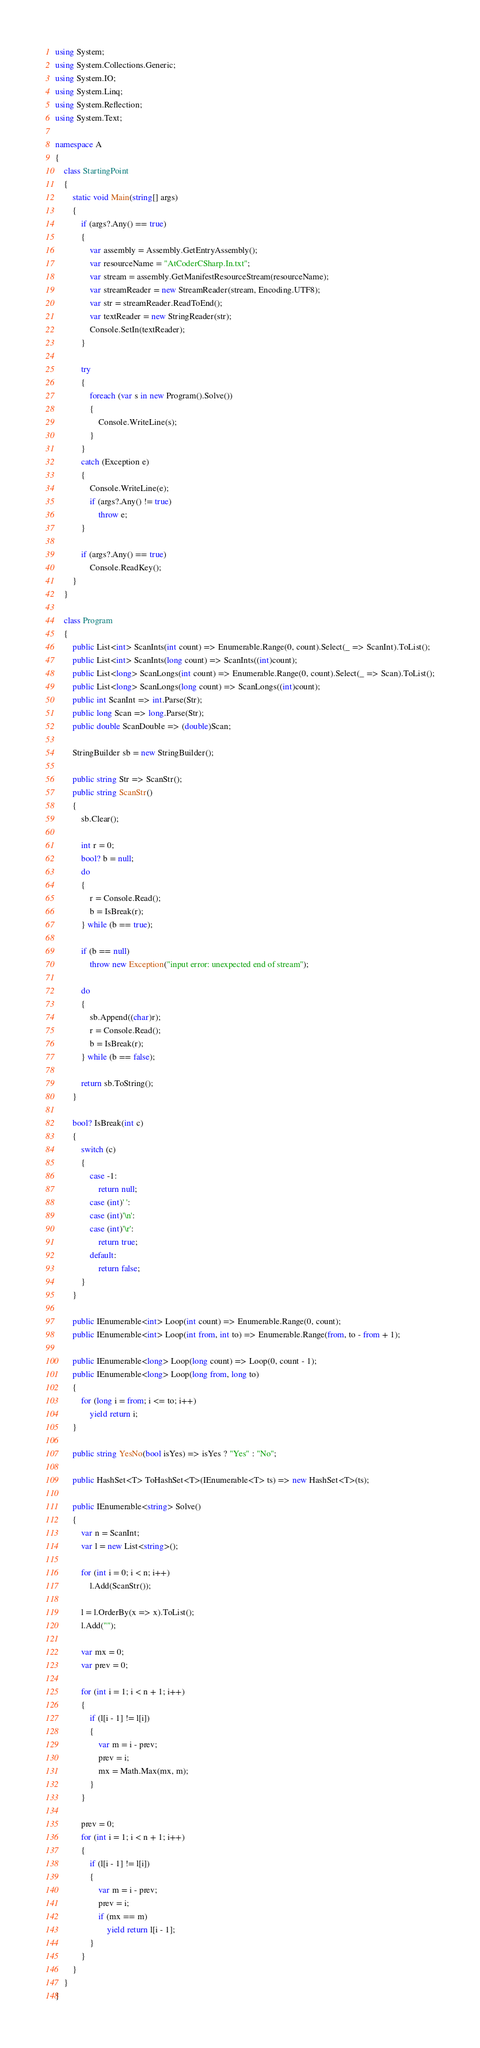Convert code to text. <code><loc_0><loc_0><loc_500><loc_500><_C#_>using System;
using System.Collections.Generic;
using System.IO;
using System.Linq;
using System.Reflection;
using System.Text;

namespace A
{
    class StartingPoint
    {
        static void Main(string[] args)
        {
            if (args?.Any() == true)
            {
                var assembly = Assembly.GetEntryAssembly();
                var resourceName = "AtCoderCSharp.In.txt";
                var stream = assembly.GetManifestResourceStream(resourceName);
                var streamReader = new StreamReader(stream, Encoding.UTF8);
                var str = streamReader.ReadToEnd();
                var textReader = new StringReader(str);
                Console.SetIn(textReader);
            }

            try
            {
                foreach (var s in new Program().Solve())
                {
                    Console.WriteLine(s);
                }
            }
            catch (Exception e)
            {
                Console.WriteLine(e);
                if (args?.Any() != true)
                    throw e;
            }

            if (args?.Any() == true)
                Console.ReadKey();
        }
    }

    class Program
    {
        public List<int> ScanInts(int count) => Enumerable.Range(0, count).Select(_ => ScanInt).ToList();
        public List<int> ScanInts(long count) => ScanInts((int)count);
        public List<long> ScanLongs(int count) => Enumerable.Range(0, count).Select(_ => Scan).ToList();
        public List<long> ScanLongs(long count) => ScanLongs((int)count);
        public int ScanInt => int.Parse(Str);
        public long Scan => long.Parse(Str);
        public double ScanDouble => (double)Scan;

        StringBuilder sb = new StringBuilder();

        public string Str => ScanStr();
        public string ScanStr()
        {
            sb.Clear();

            int r = 0;
            bool? b = null;
            do
            {
                r = Console.Read();
                b = IsBreak(r);
            } while (b == true);

            if (b == null)
                throw new Exception("input error: unexpected end of stream");

            do
            {
                sb.Append((char)r);
                r = Console.Read();
                b = IsBreak(r);
            } while (b == false);

            return sb.ToString();
        }

        bool? IsBreak(int c)
        {
            switch (c)
            {
                case -1:
                    return null;
                case (int)' ':
                case (int)'\n':
                case (int)'\r':
                    return true;
                default:
                    return false;
            }
        }

        public IEnumerable<int> Loop(int count) => Enumerable.Range(0, count);
        public IEnumerable<int> Loop(int from, int to) => Enumerable.Range(from, to - from + 1);

        public IEnumerable<long> Loop(long count) => Loop(0, count - 1);
        public IEnumerable<long> Loop(long from, long to)
        {
            for (long i = from; i <= to; i++)
                yield return i;
        }

        public string YesNo(bool isYes) => isYes ? "Yes" : "No";

        public HashSet<T> ToHashSet<T>(IEnumerable<T> ts) => new HashSet<T>(ts);

        public IEnumerable<string> Solve()
        {
            var n = ScanInt;
            var l = new List<string>();

            for (int i = 0; i < n; i++)
                l.Add(ScanStr());

            l = l.OrderBy(x => x).ToList();
            l.Add("");

            var mx = 0;
            var prev = 0;

            for (int i = 1; i < n + 1; i++)
            {
                if (l[i - 1] != l[i])
                {
                    var m = i - prev;
                    prev = i;
                    mx = Math.Max(mx, m);
                }
            }

            prev = 0;
            for (int i = 1; i < n + 1; i++)
            {
                if (l[i - 1] != l[i])
                {
                    var m = i - prev;
                    prev = i;
                    if (mx == m)
                        yield return l[i - 1];
                }
            }
        }
    }
}</code> 